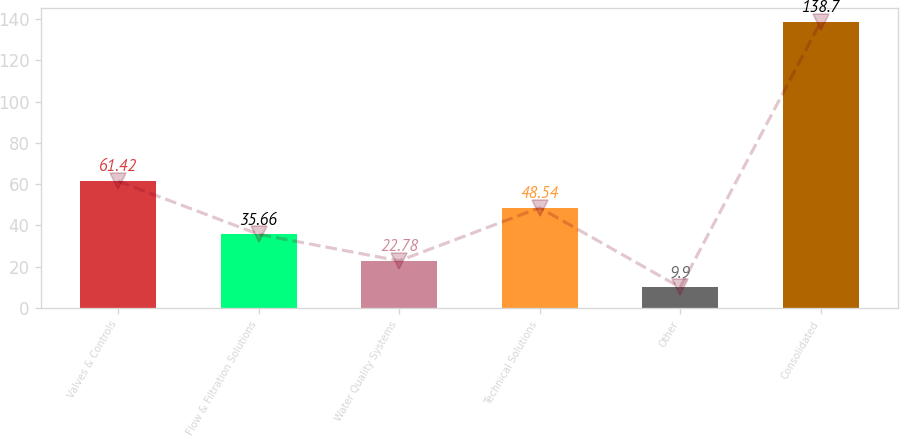Convert chart. <chart><loc_0><loc_0><loc_500><loc_500><bar_chart><fcel>Valves & Controls<fcel>Flow & Filtration Solutions<fcel>Water Quality Systems<fcel>Technical Solutions<fcel>Other<fcel>Consolidated<nl><fcel>61.42<fcel>35.66<fcel>22.78<fcel>48.54<fcel>9.9<fcel>138.7<nl></chart> 